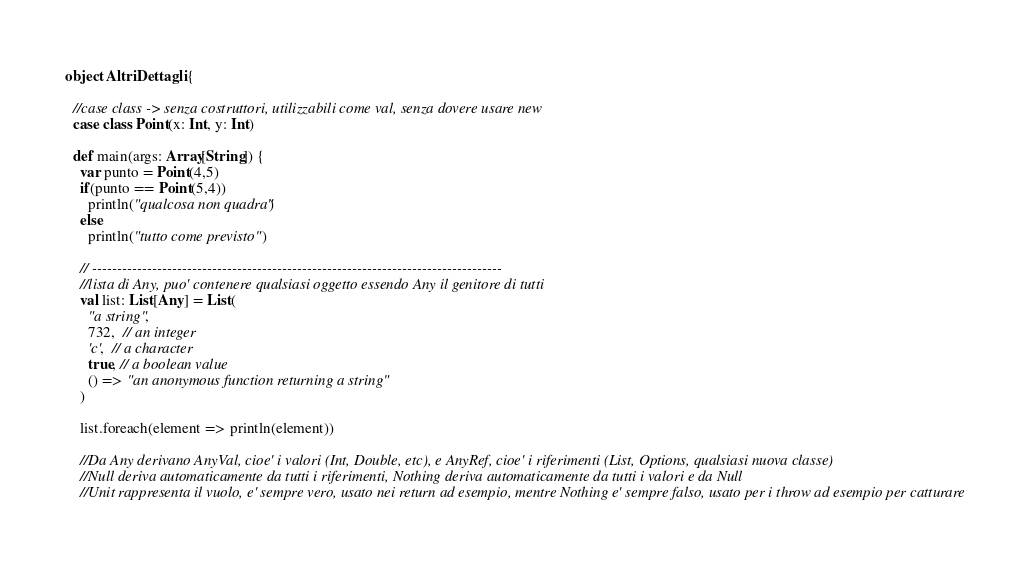Convert code to text. <code><loc_0><loc_0><loc_500><loc_500><_Scala_>object AltriDettagli {
  
  //case class -> senza costruttori, utilizzabili come val, senza dovere usare new
  case class Point(x: Int, y: Int)

  def main(args: Array[String]) {
    var punto = Point(4,5)
    if(punto == Point(5,4))
      println("qualcosa non quadra")
    else
      println("tutto come previsto")

    // ----------------------------------------------------------------------------------
    //lista di Any, puo' contenere qualsiasi oggetto essendo Any il genitore di tutti
    val list: List[Any] = List(
      "a string",
      732,  // an integer
      'c',  // a character
      true, // a boolean value
      () => "an anonymous function returning a string"
    )
    
    list.foreach(element => println(element))

    //Da Any derivano AnyVal, cioe' i valori (Int, Double, etc), e AnyRef, cioe' i riferimenti (List, Options, qualsiasi nuova classe)
    //Null deriva automaticamente da tutti i riferimenti, Nothing deriva automaticamente da tutti i valori e da Null
    //Unit rappresenta il vuolo, e' sempre vero, usato nei return ad esempio, mentre Nothing e' sempre falso, usato per i throw ad esempio per catturare</code> 